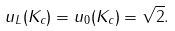<formula> <loc_0><loc_0><loc_500><loc_500>u _ { L } ( K _ { c } ) = u _ { 0 } ( K _ { c } ) = \sqrt { 2 } .</formula> 